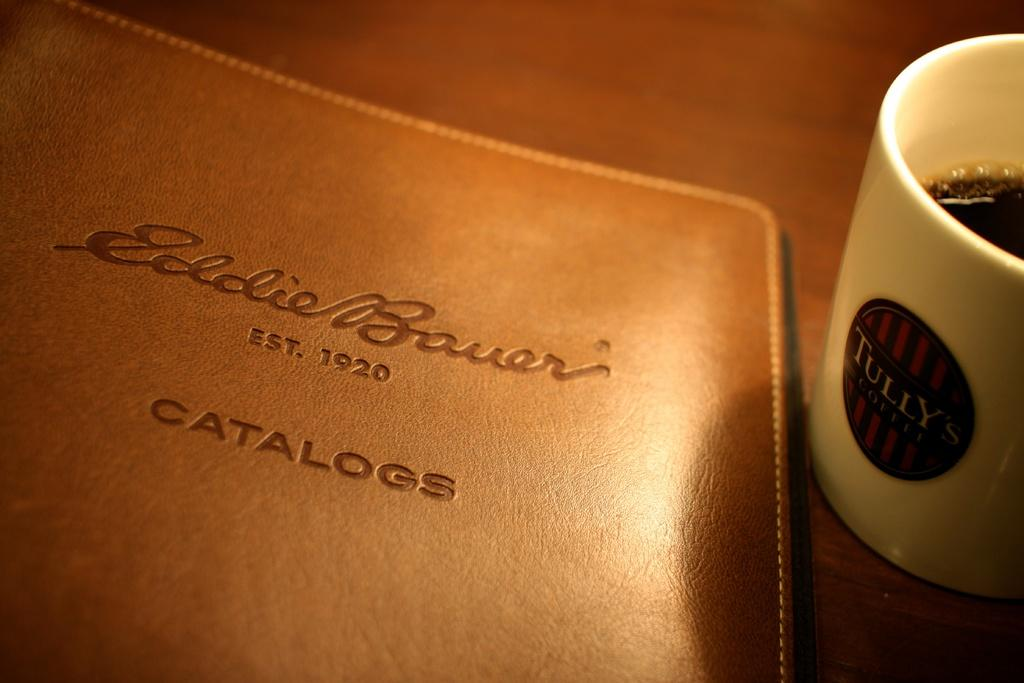What is on the table in the image? There is a cup and a file on the table. What is inside the cup? The cup contains black tea. Where is the throne located in the image? There is no throne present in the image. How does the stomach feel after consuming the black tea in the image? The image does not provide information about how the stomach feels after consuming the black tea, as it only shows the cup containing the tea. 